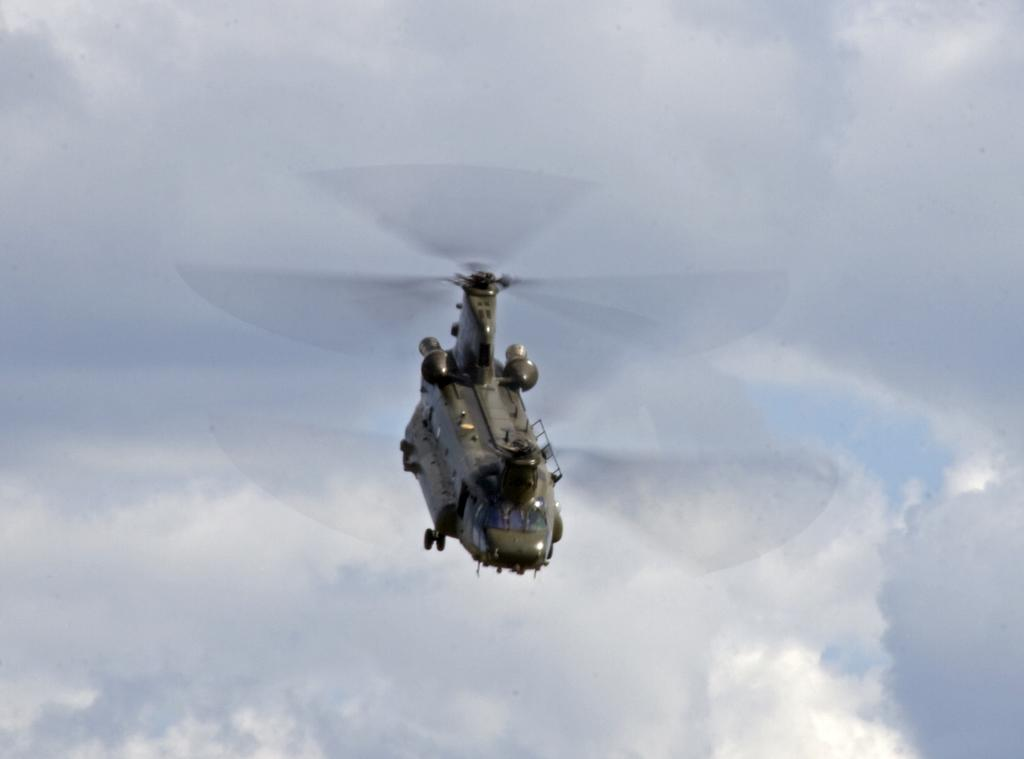What is the main subject of the image? The main subject of the image is a helicopter. What can be seen in the background of the image? The sky is visible in the image. Are there any weather conditions depicted in the image? Yes, clouds are present in the sky. How many boats can be seen in the image? There are no boats present in the image; it features a helicopter and clouds in the sky. What type of spy equipment is visible in the image? There is no spy equipment visible in the image; it only shows a helicopter and clouds in the sky. 